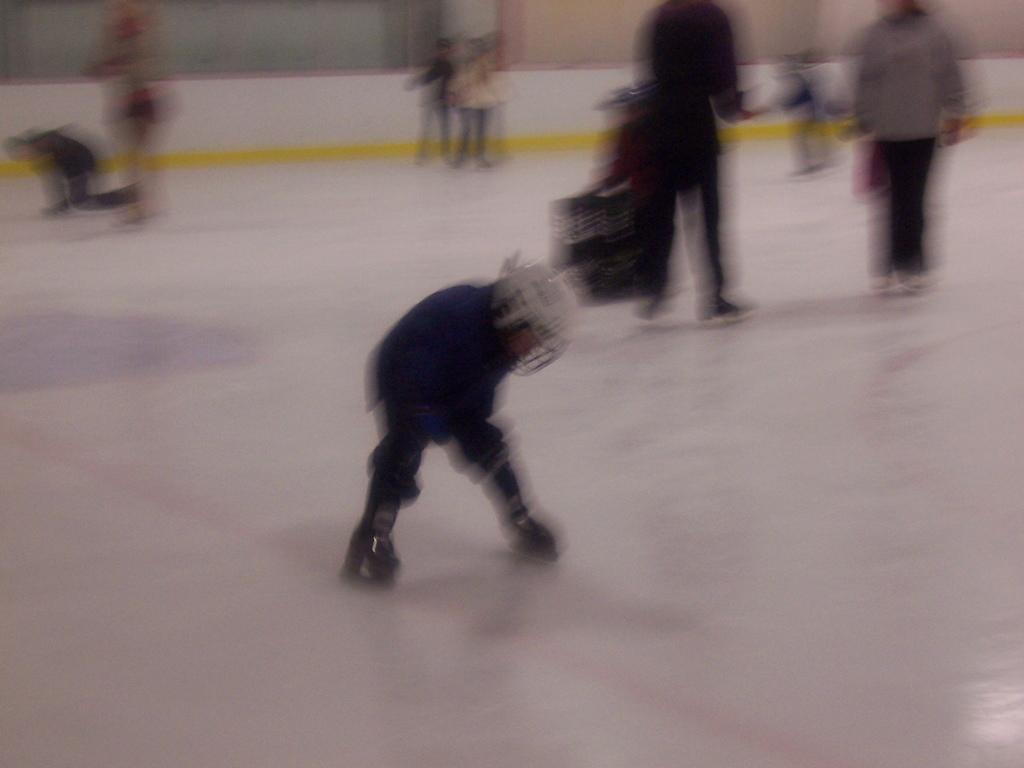Who or what is present in the image? There are people in the image. What are the people doing in the image? The people are skating on an ice floor. What type of grass can be seen growing on the level surface in the image? There is no grass present in the image; the people are skating on an ice floor. 